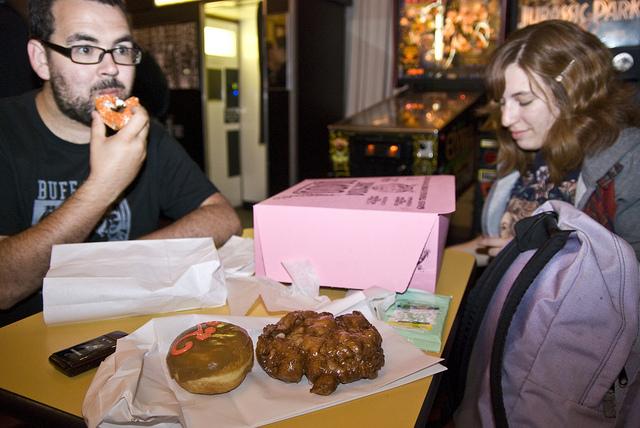Is there a candle on the table?
Be succinct. No. Does the man on the left have facial hair?
Concise answer only. Yes. What is the color of the box on the table?
Write a very short answer. Pink. What was the occasion?
Answer briefly. Birthday. 